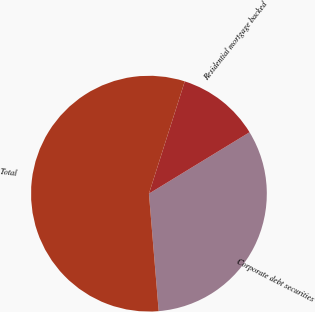<chart> <loc_0><loc_0><loc_500><loc_500><pie_chart><fcel>Corporate debt securities<fcel>Residential mortgage backed<fcel>Total<nl><fcel>32.4%<fcel>11.36%<fcel>56.23%<nl></chart> 